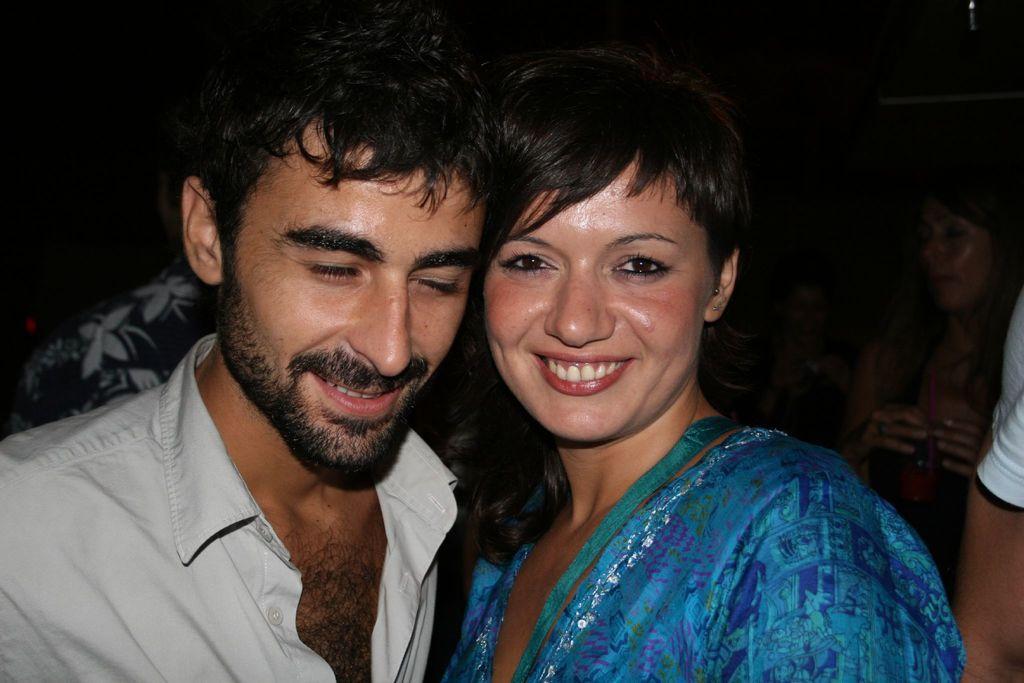How would you summarize this image in a sentence or two? In this image I can see few people and I can also see smile on few faces. 